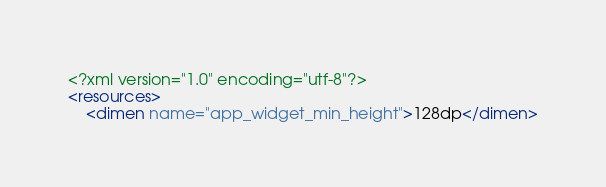<code> <loc_0><loc_0><loc_500><loc_500><_XML_><?xml version="1.0" encoding="utf-8"?>
<resources>
    <dimen name="app_widget_min_height">128dp</dimen></code> 